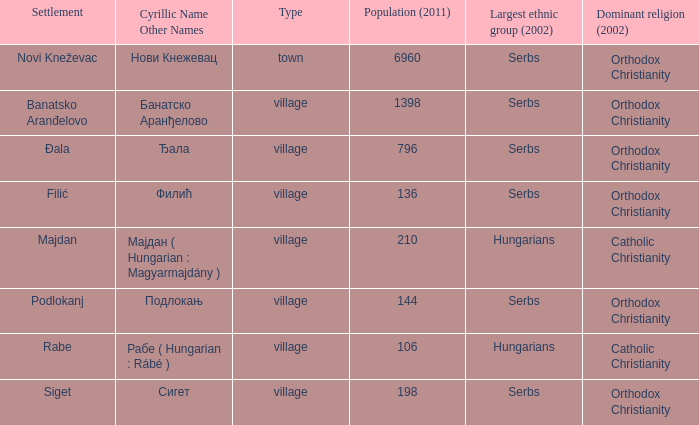Which settlement has the cyrillic name сигет?  Siget. 